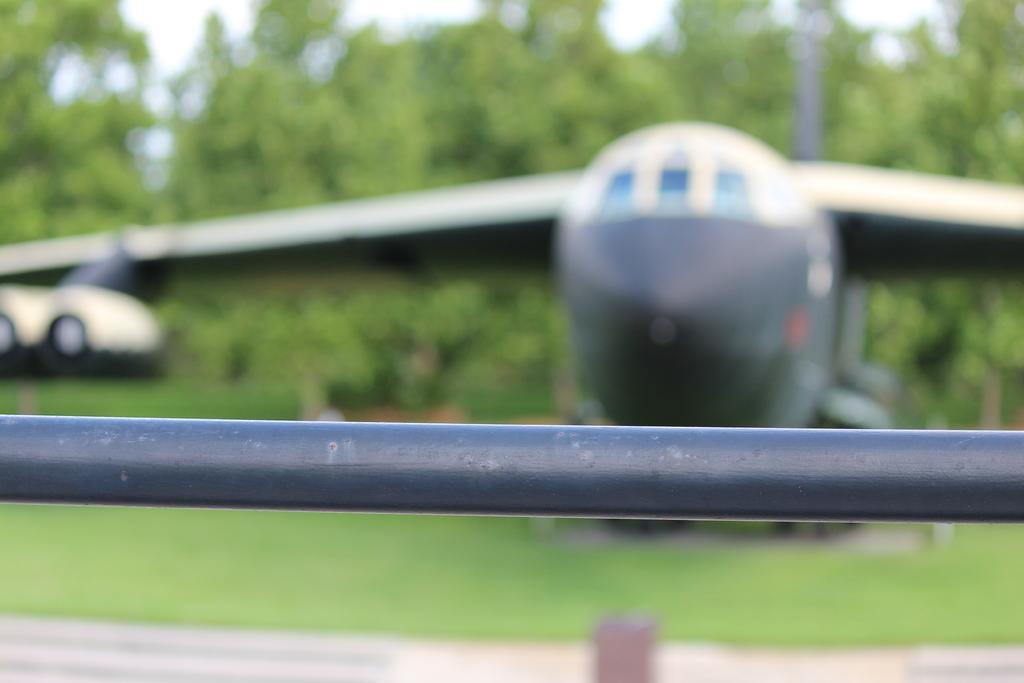How would you summarize this image in a sentence or two? There is a road at the bottom of this image. We can see an airplane in the middle of this image and there are trees in the background. 